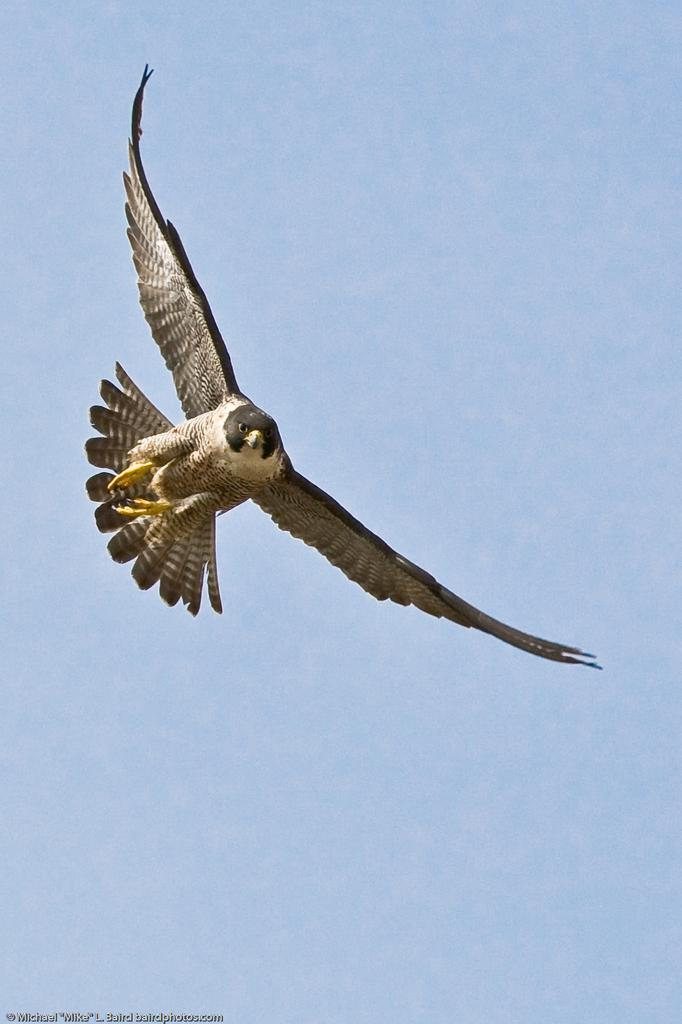What type of bird is in the picture? There is a brown color eagle in the picture. What is the eagle doing in the picture? The eagle is flying in the sky. What color is the sky in the picture? The sky is blue. Where is the badge located in the picture? There is no badge present in the picture. What type of school can be seen in the picture? There is no school present in the picture. 